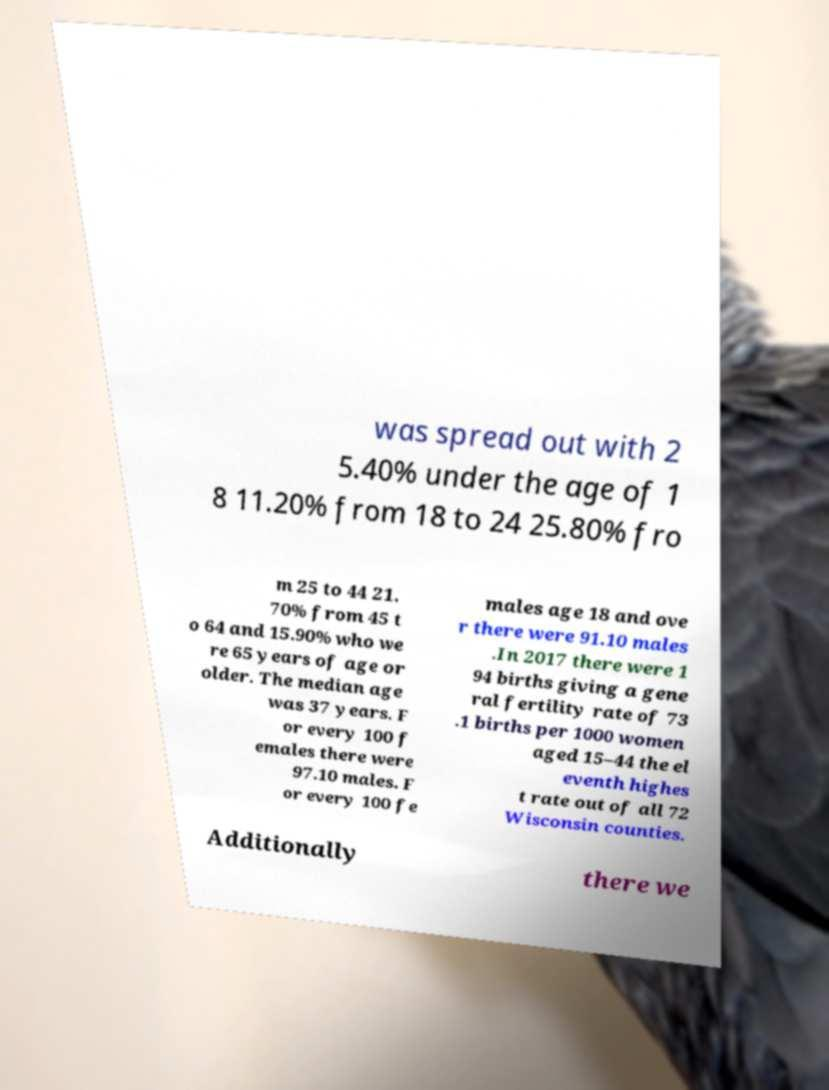Please identify and transcribe the text found in this image. was spread out with 2 5.40% under the age of 1 8 11.20% from 18 to 24 25.80% fro m 25 to 44 21. 70% from 45 t o 64 and 15.90% who we re 65 years of age or older. The median age was 37 years. F or every 100 f emales there were 97.10 males. F or every 100 fe males age 18 and ove r there were 91.10 males .In 2017 there were 1 94 births giving a gene ral fertility rate of 73 .1 births per 1000 women aged 15–44 the el eventh highes t rate out of all 72 Wisconsin counties. Additionally there we 